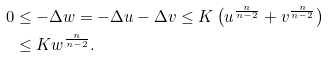Convert formula to latex. <formula><loc_0><loc_0><loc_500><loc_500>0 & \leq - \Delta w = - \Delta u - \Delta v \leq K \left ( u ^ { \frac { n } { n - 2 } } + v ^ { \frac { n } { n - 2 } } \right ) \\ & \leq K w ^ { \frac { n } { n - 2 } } .</formula> 